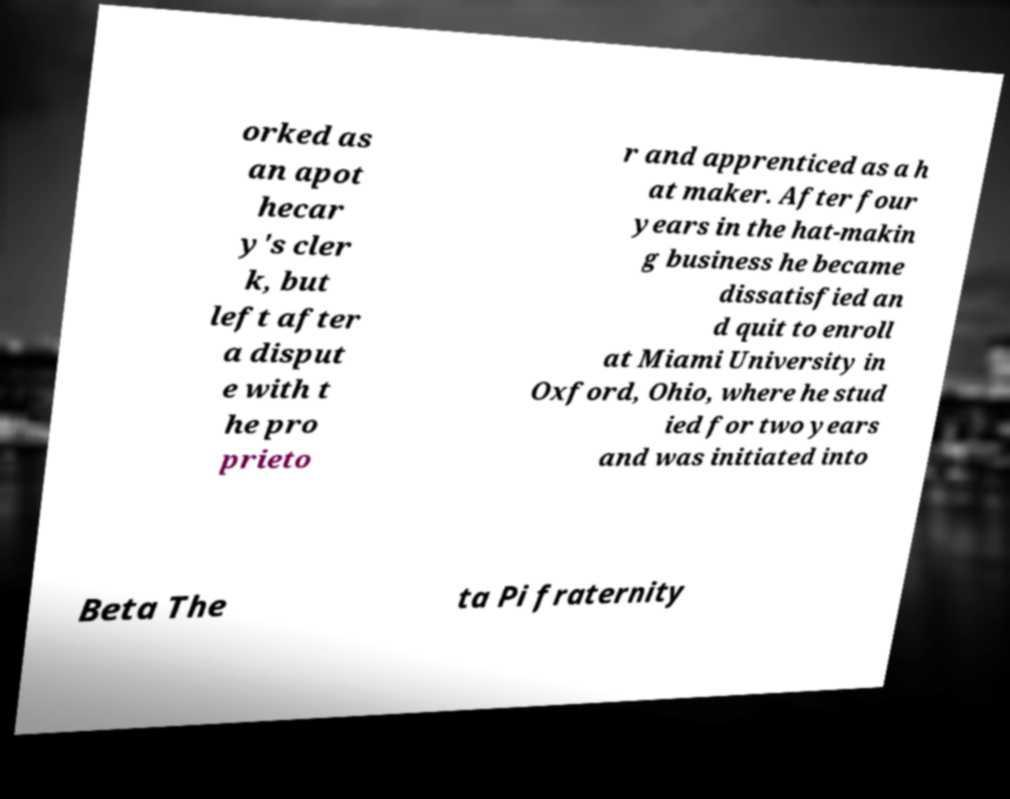I need the written content from this picture converted into text. Can you do that? orked as an apot hecar y's cler k, but left after a disput e with t he pro prieto r and apprenticed as a h at maker. After four years in the hat-makin g business he became dissatisfied an d quit to enroll at Miami University in Oxford, Ohio, where he stud ied for two years and was initiated into Beta The ta Pi fraternity 